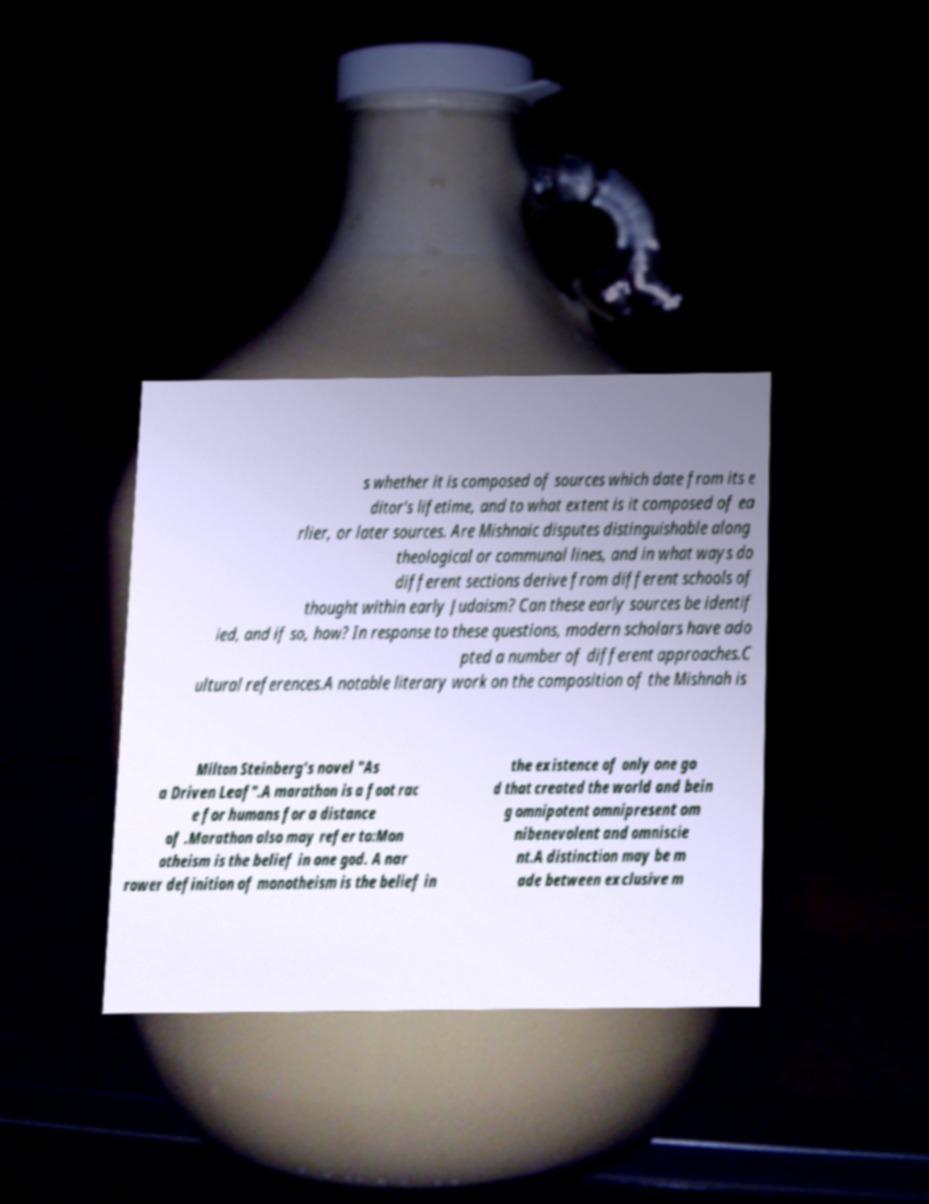Please identify and transcribe the text found in this image. s whether it is composed of sources which date from its e ditor's lifetime, and to what extent is it composed of ea rlier, or later sources. Are Mishnaic disputes distinguishable along theological or communal lines, and in what ways do different sections derive from different schools of thought within early Judaism? Can these early sources be identif ied, and if so, how? In response to these questions, modern scholars have ado pted a number of different approaches.C ultural references.A notable literary work on the composition of the Mishnah is Milton Steinberg's novel "As a Driven Leaf".A marathon is a foot rac e for humans for a distance of .Marathon also may refer to:Mon otheism is the belief in one god. A nar rower definition of monotheism is the belief in the existence of only one go d that created the world and bein g omnipotent omnipresent om nibenevolent and omniscie nt.A distinction may be m ade between exclusive m 